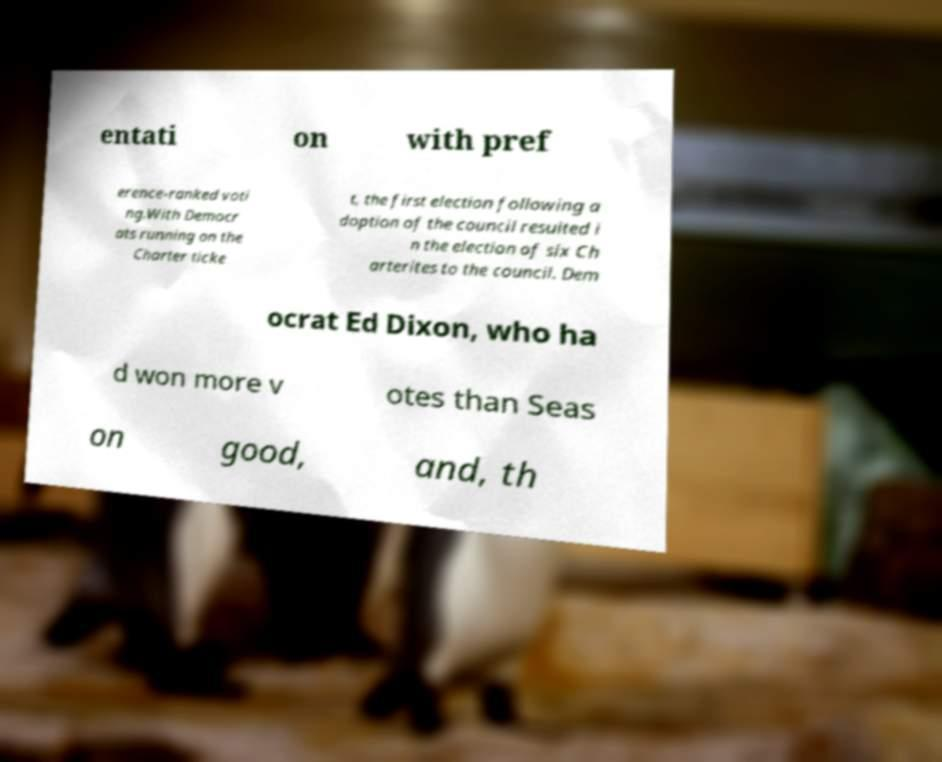What messages or text are displayed in this image? I need them in a readable, typed format. entati on with pref erence-ranked voti ng.With Democr ats running on the Charter ticke t, the first election following a doption of the council resulted i n the election of six Ch arterites to the council. Dem ocrat Ed Dixon, who ha d won more v otes than Seas on good, and, th 